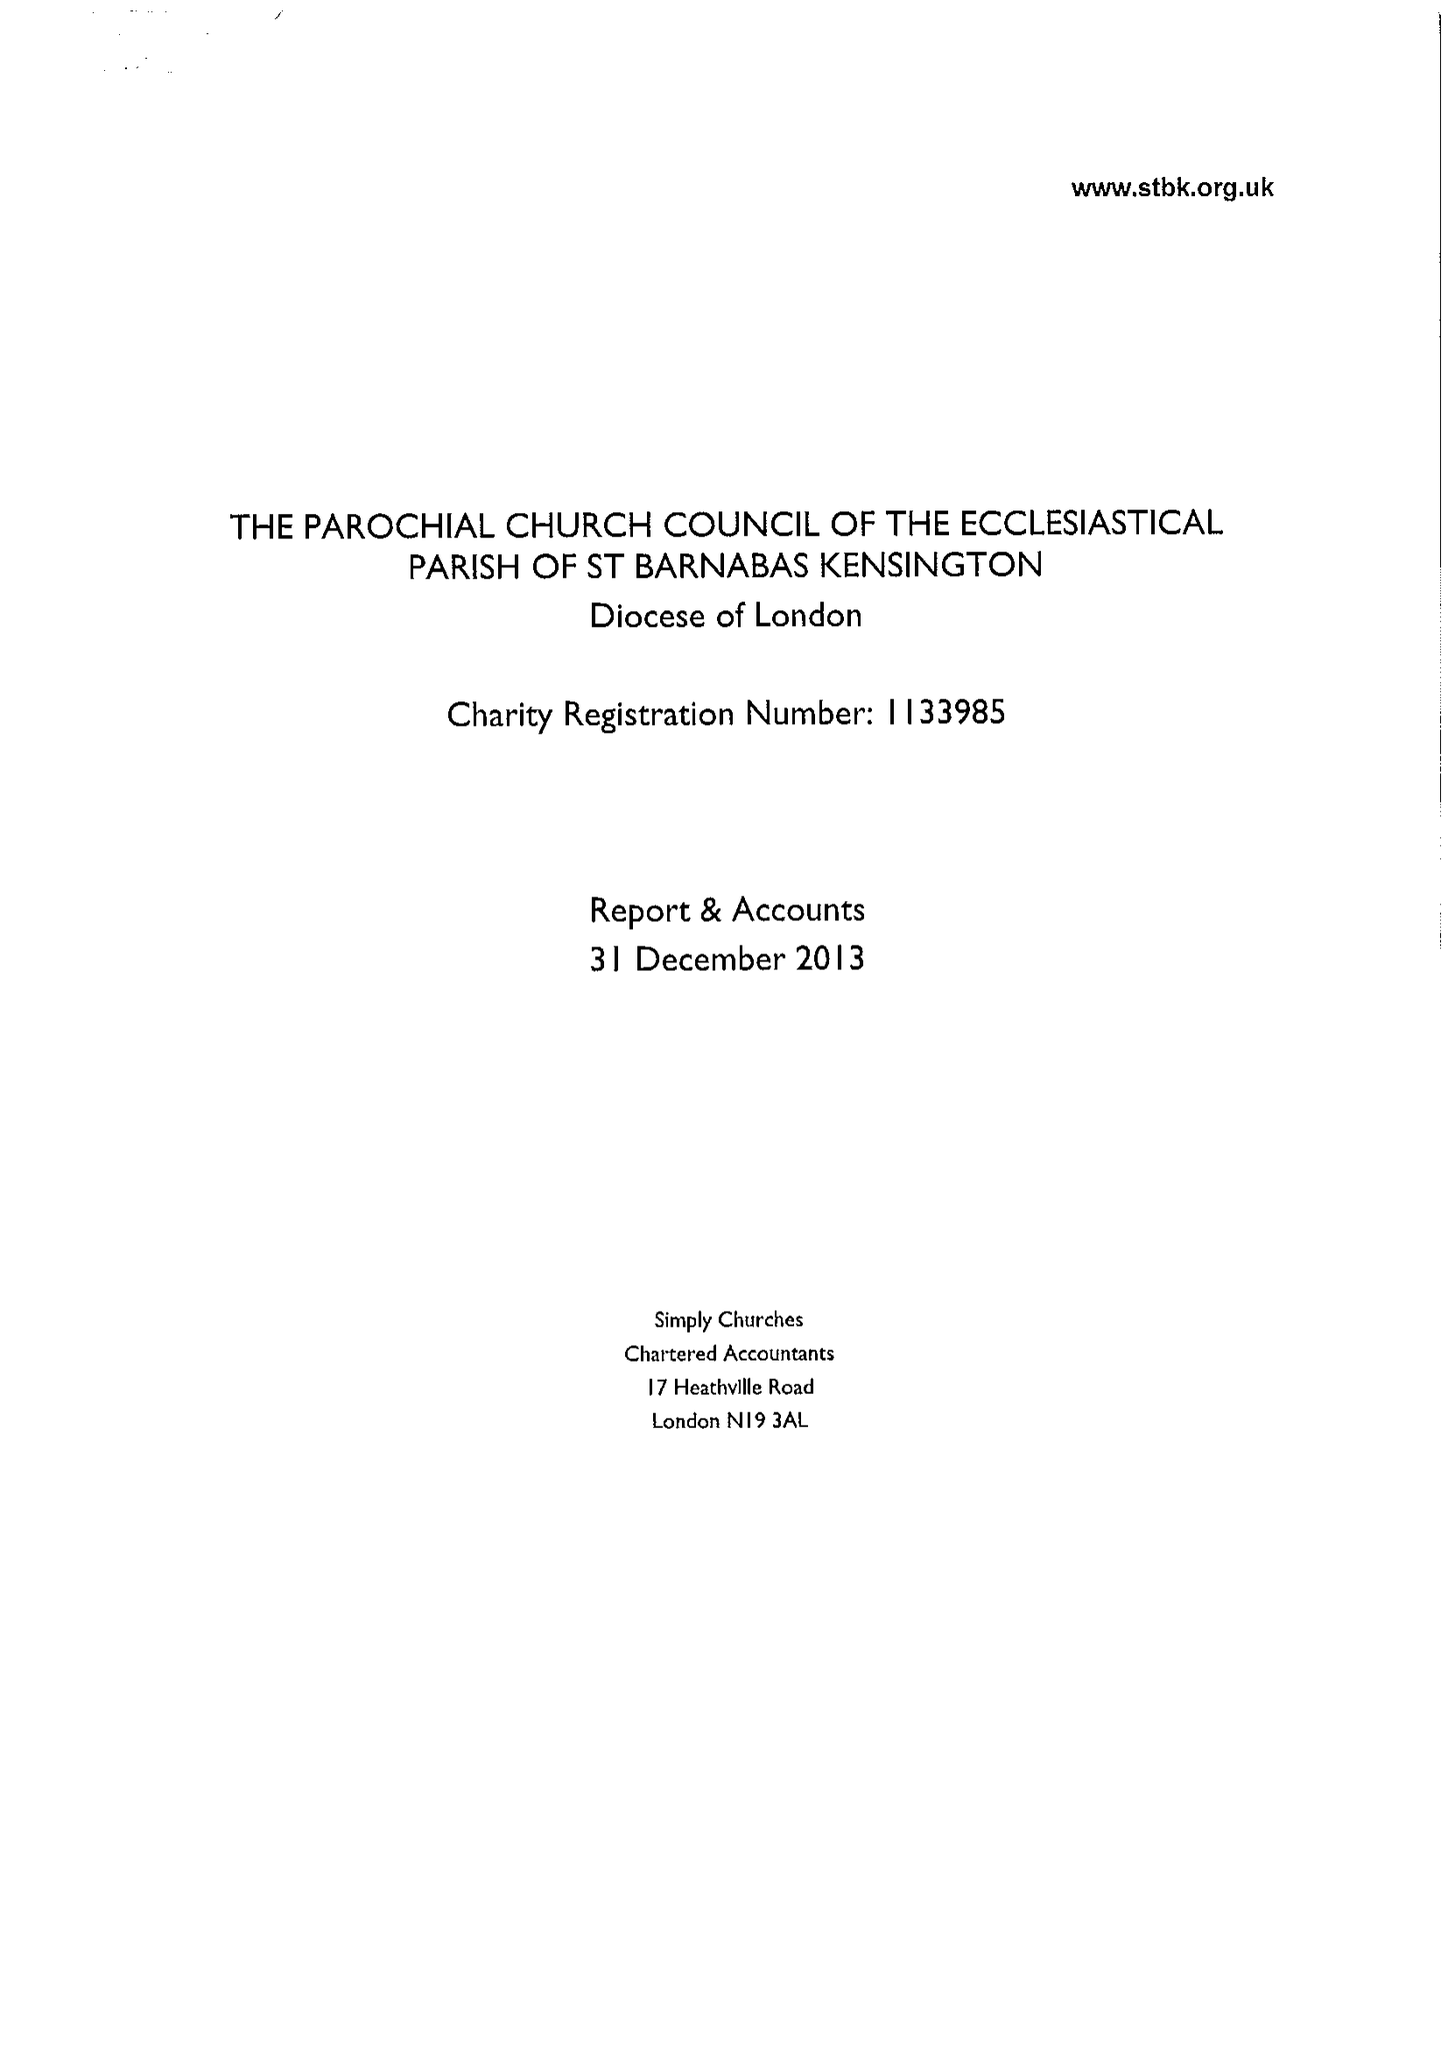What is the value for the income_annually_in_british_pounds?
Answer the question using a single word or phrase. 527522.00 